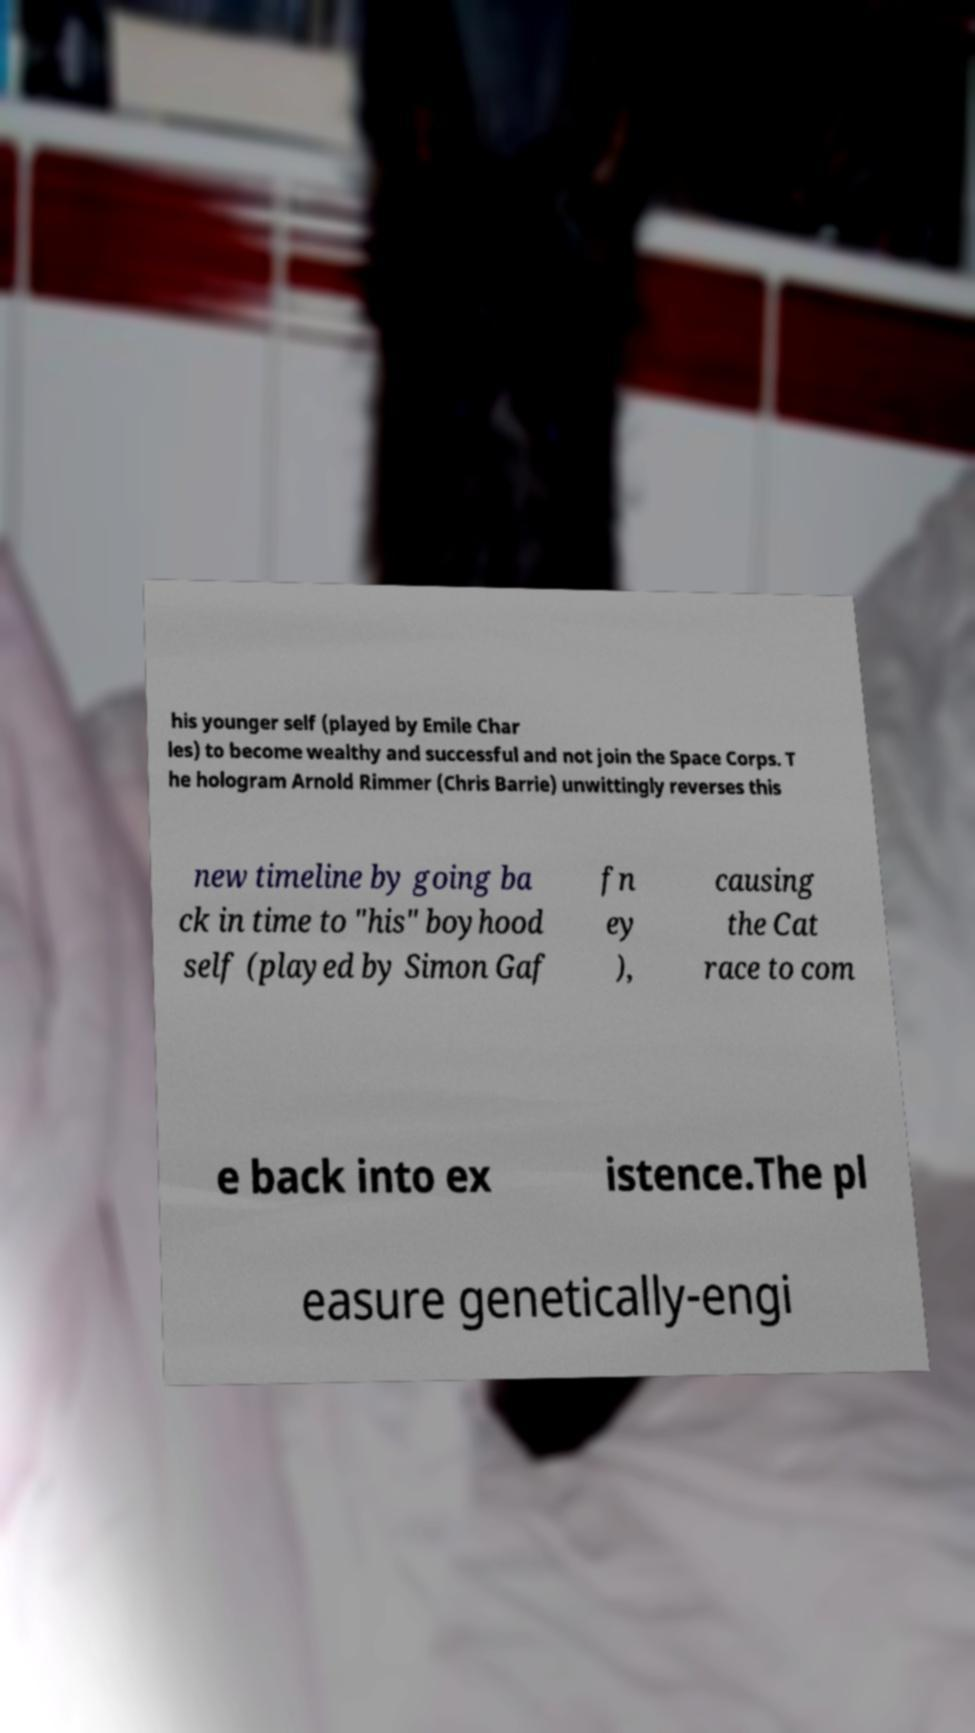I need the written content from this picture converted into text. Can you do that? his younger self (played by Emile Char les) to become wealthy and successful and not join the Space Corps. T he hologram Arnold Rimmer (Chris Barrie) unwittingly reverses this new timeline by going ba ck in time to "his" boyhood self (played by Simon Gaf fn ey ), causing the Cat race to com e back into ex istence.The pl easure genetically-engi 